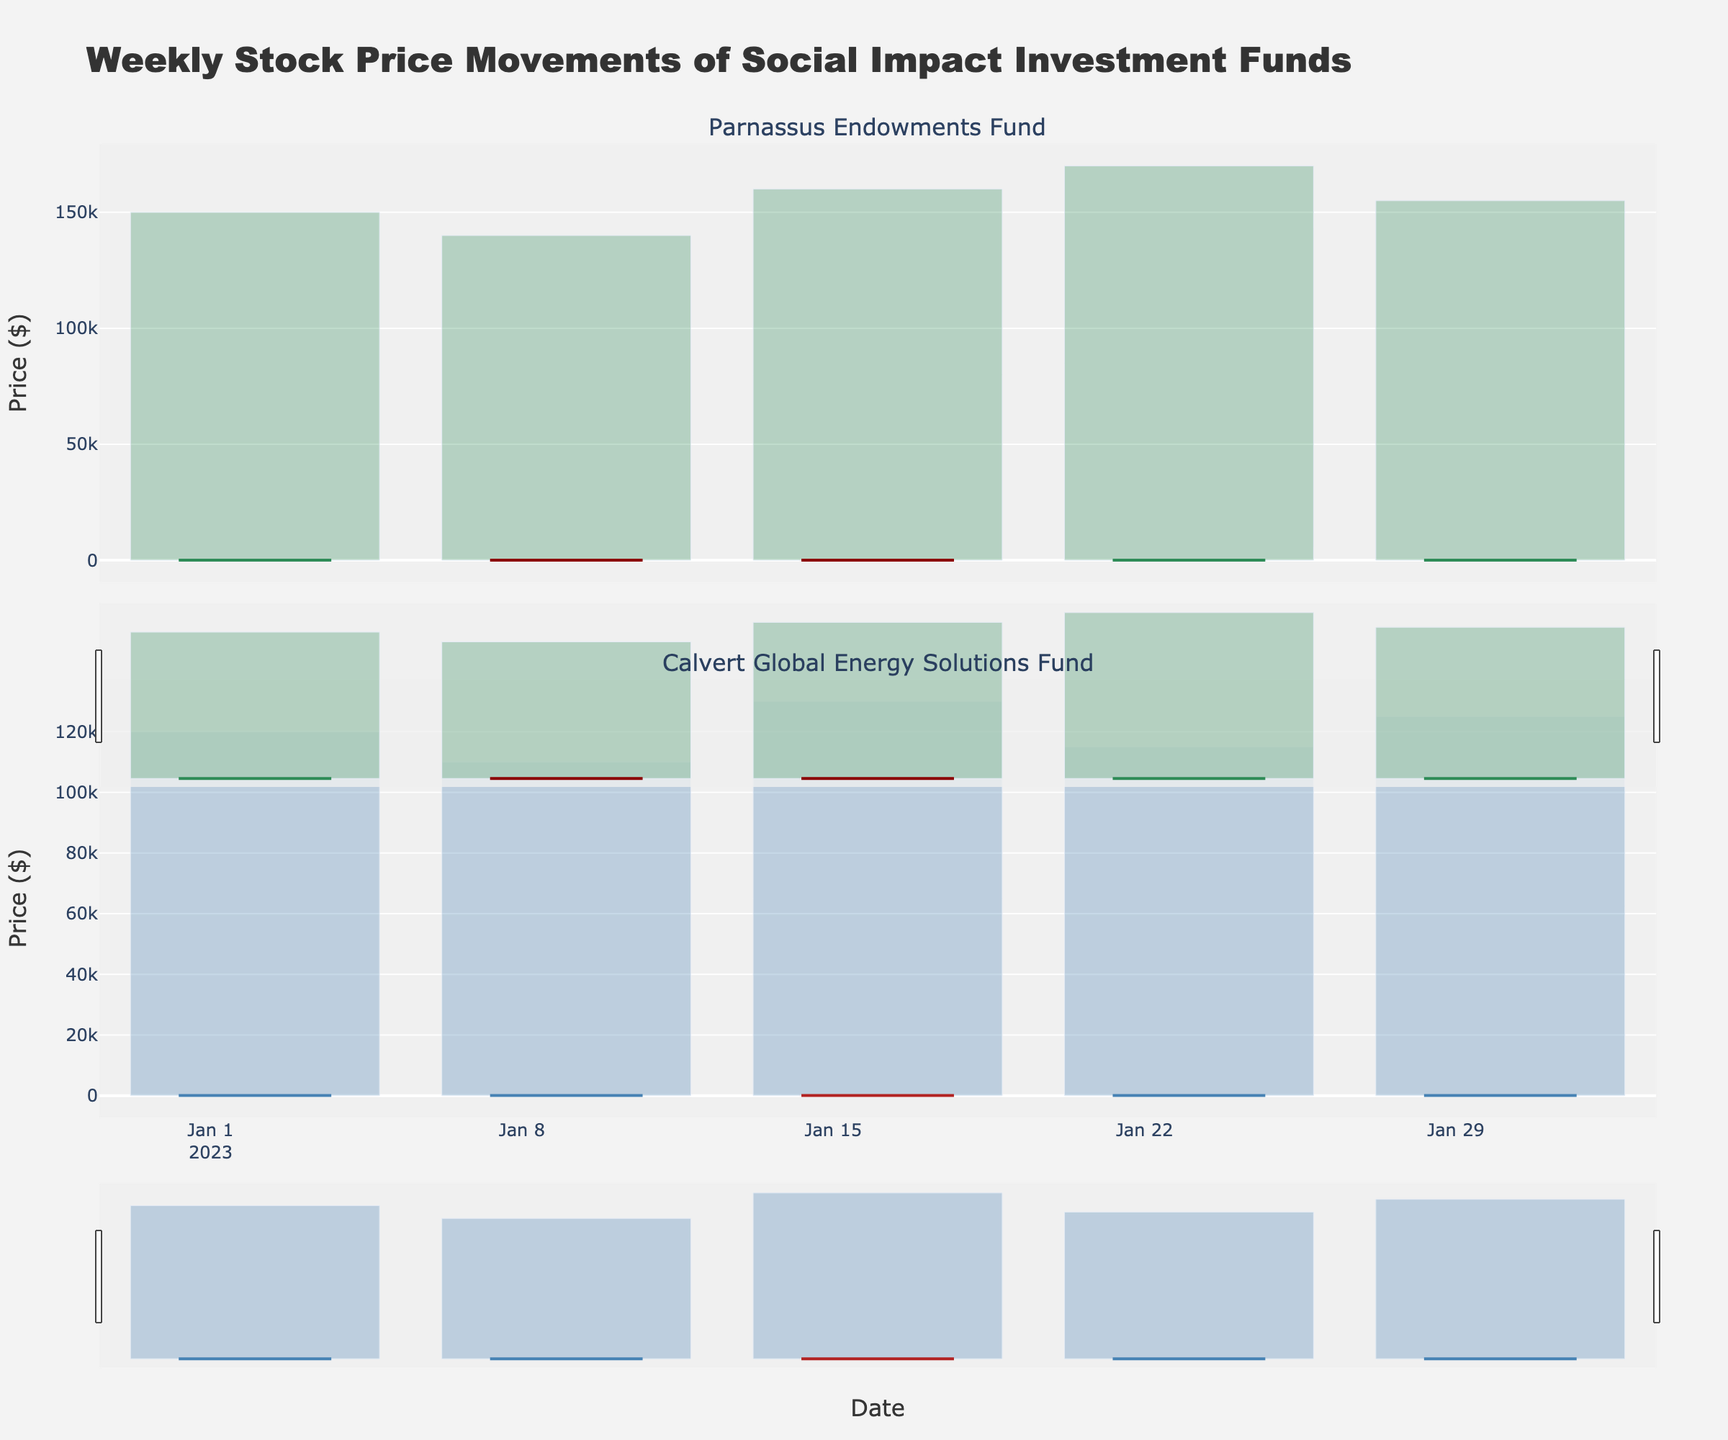What is the title of the figure? The title is displayed at the top of the figure. It reads "Weekly Stock Price Movements of Social Impact Investment Funds".
Answer: Weekly Stock Price Movements of Social Impact Investment Funds What are the subplot titles in the figure? The subplot titles are shown above each candlestick chart. The first subplot is titled "Parnassus Endowments Fund" and the second is "Calvert Global Energy Solutions Fund".
Answer: Parnassus Endowments Fund, Calvert Global Energy Solutions Fund During which week did the Parnassus Endowments Fund have the highest closing price? By examining the closing prices in the candlestick plots, we see that the highest closing price for the Parnassus Endowments Fund occurred on the week of 2023-01-30 with a closing price of 41.90.
Answer: 2023-01-30 What color represents increasing stock prices for the Calvert Global Energy Solutions Fund? The color for increasing stock prices in the Calvert Global Energy Solutions Fund plot is indicated by the line color on the positive (upward) candlesticks. It is blue.
Answer: Blue How does the volume traded compare between Parnassus Endowments Fund and Calvert Global Energy Solutions Fund on the week of 2023-01-23? By examining the bar charts below the candlestick plots, we observe that Parnassus Endowments Fund had a trading volume of 170,000, while Calvert Global Energy Solutions Fund had a volume of 115,000 during the week of 2023-01-23.
Answer: Parnassus had a higher volume Which fund showed an overall increasing trend in their closing prices through January? By analyzing the trends in the candlestick plots, we can see that the Parnassus Endowments Fund has a generally increasing trend in closing prices, increasing from approximately 41.40 at the beginning to 41.90 at the end of January.
Answer: Parnassus Endowments Fund Compare the number of increasing weeks (where closing price is higher than the opening price) between the two funds in January. Count the weeks in the candlestick plots where the closing price is greater than the opening price for each fund. Parnassus has 3 weeks, while Calvert has 3 weeks with a closing price higher than the opening price in January.
Answer: Both funds have 3 increasing weeks How did the Emerging Market Index trend over the month of January? The Emerging Market Index trend is displayed as a line across both subplots. It shows a consistent upward trend over the month, starting at MSCI_EM_1300 and gradually increasing to MSCI_EM_1350.
Answer: Upward trend What is the difference in closing prices of the Calvert Global Energy Solutions Fund between the first and last week in January? By looking at the closing prices for the Calvert Global Energy Solutions Fund, the closing price was 18.70 on 2023-01-02 and 18.95 on 2023-01-30. The difference is calculated as 18.95 - 18.70.
Answer: 0.25 During which week did the Calvert Global Energy Solutions Fund experience the largest range between its high and low prices? Examine the range between high and low prices in each week's candlestick for Calvert Global Energy Solutions Fund. The largest range (0.80) was on the week of 2023-01-16 where the high was 19.10 and the low was 18.30.
Answer: 2023-01-16 